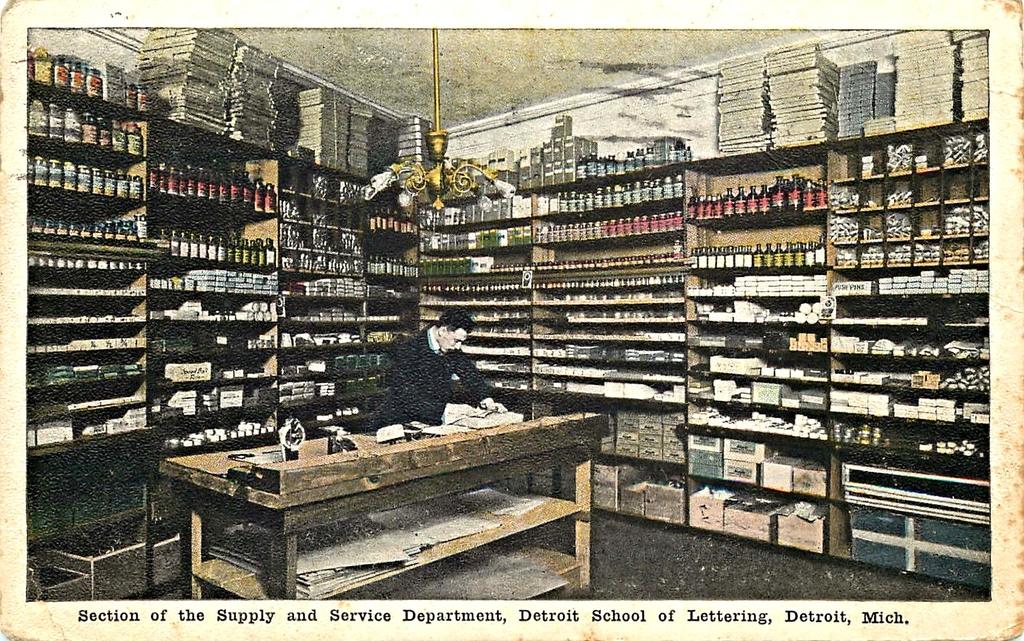Where was this photo taken?
Your answer should be very brief. Detroit. 